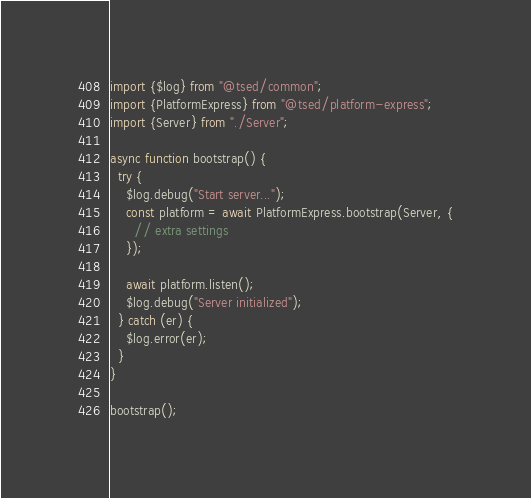<code> <loc_0><loc_0><loc_500><loc_500><_TypeScript_>import {$log} from "@tsed/common";
import {PlatformExpress} from "@tsed/platform-express";
import {Server} from "./Server";

async function bootstrap() {
  try {
    $log.debug("Start server...");
    const platform = await PlatformExpress.bootstrap(Server, {
      // extra settings
    });

    await platform.listen();
    $log.debug("Server initialized");
  } catch (er) {
    $log.error(er);
  }
}

bootstrap();</code> 